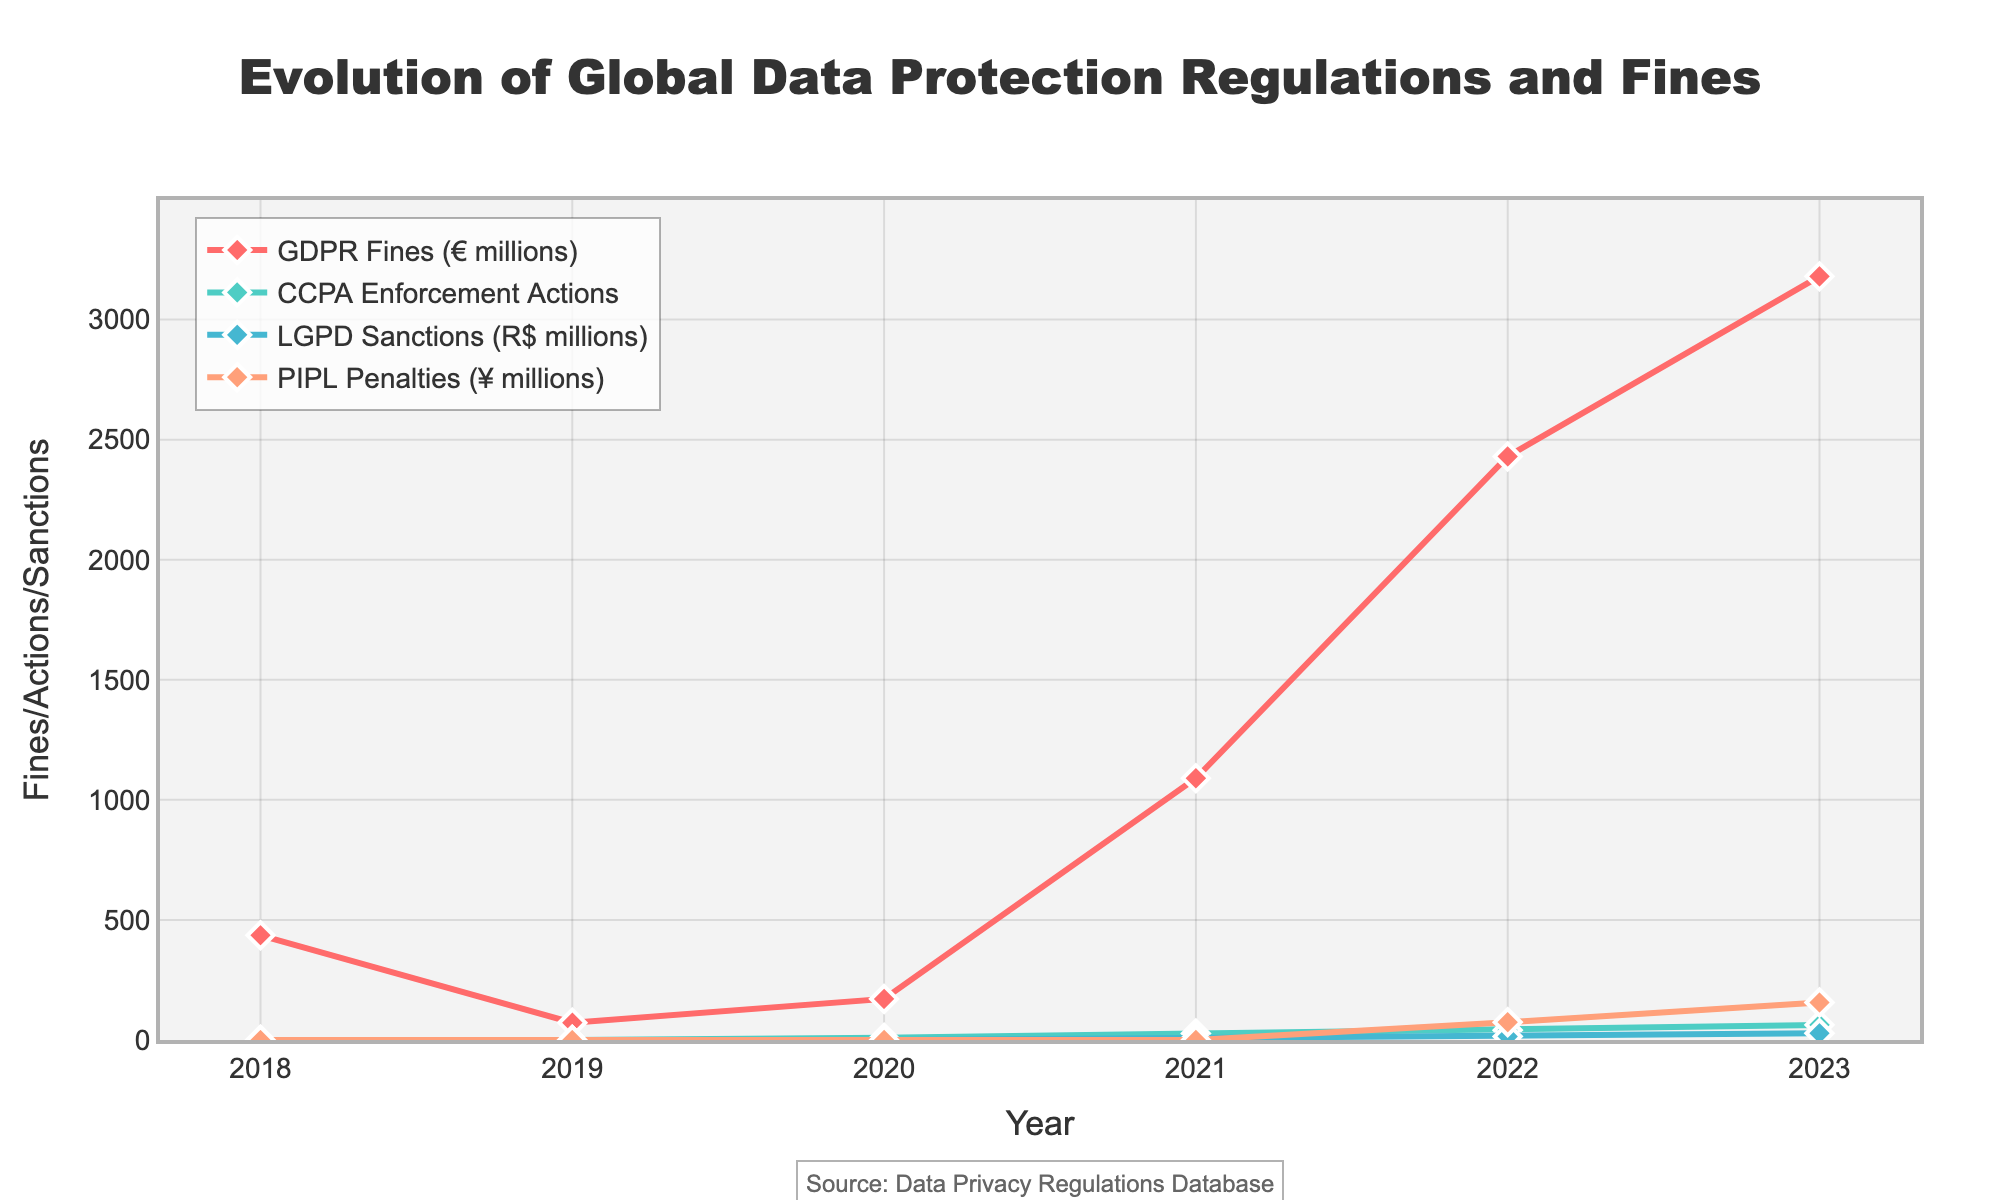What is the trend of GDPR fines from 2018 to 2023? The GDPR fines show an overall increasing trend from 2018 to 2023, with a significant spike in 2021 and 2022. The values start at 436 million euros in 2018 and reach 3180 million euros in 2023.
Answer: Increasing trend Which year saw the highest amount for GDPR fines, and what was the amount? The highest amount for GDPR fines was in 2023, where the fines reached 3180 million euros. This can be observed by identifying the peak value on the line representing GDPR fines.
Answer: 2023, 3180 million euros How do CCPA enforcement actions compare between 2020 and 2023? CCPA enforcement actions increase significantly from 9 actions in 2020 to 63 actions in 2023. This comparison can be seen by looking at the values on the CCPA line for the corresponding years.
Answer: Increased from 9 to 63 How many times larger were PIPL penalties in 2023 compared to 2022? From the figure, PIPL penalties in 2023 are 156 million yuan, and in 2022 they were 74 million yuan. To find how many times larger, we divide 156 by 74, resulting in approximately 2.11.
Answer: About 2.11 times larger What is the average amount of LGPD sanctions from 2021 to 2023? To find the average, we sum the LGPD sanction amounts for 2021 (8 million reais), 2022 (15 million reais), and 2023 (28 million reais) which total 51 million reais. Then, divide by 3 (the number of years) to get 17 million reais.
Answer: 17 million reais Between GDPR fines and PIPL penalties, which exhibited a steeper increase from 2022 to 2023? GDPR fines went from 2430 million euros in 2022 to 3180 million euros in 2023, an increase of 750 million euros. PIPL penalties went from 74 million yuan in 2022 to 156 million yuan in 2023, an increase of 82 million yuan. The steeper increase, in absolute terms, is observed with GDPR fines.
Answer: GDPR fines What visual difference is there between the trend lines of GDPR fines and LGPD sanctions? The GDPR fines line shows a steep and consistent upward trend with noticeable spikes, whereas the LGPD sanctions line starts at zero, shows a slower but steady increase, and contains much lower values compared to GDPR fines.
Answer: GDPR fines are steeper and higher Compare the fines/sanctions/penalties of all regulations for the year 2021. Which regulation has the highest and which has the lowest? In 2021, GDPR fines are 1090 million euros, CCPA enforcement actions are 27, LGPD sanctions are 8 million reais, and PIPL penalties are 0. GDPR has the highest with 1090 million euros, and PIPL penalties are the lowest with 0.
Answer: GDPR fines highest, PIPL penalties lowest 